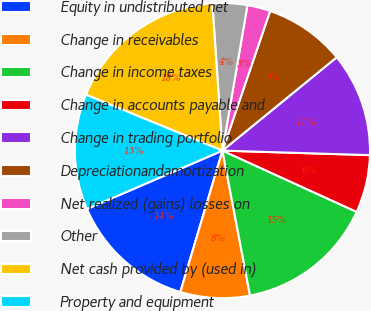Convert chart. <chart><loc_0><loc_0><loc_500><loc_500><pie_chart><fcel>Equity in undistributed net<fcel>Change in receivables<fcel>Change in income taxes<fcel>Change in accounts payable and<fcel>Change in trading portfolio<fcel>Depreciationandamortization<fcel>Net realized (gains) losses on<fcel>Other<fcel>Net cash provided by (used in)<fcel>Property and equipment<nl><fcel>13.92%<fcel>7.6%<fcel>15.19%<fcel>6.33%<fcel>11.39%<fcel>8.86%<fcel>2.53%<fcel>3.8%<fcel>17.72%<fcel>12.66%<nl></chart> 